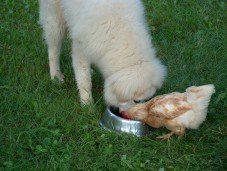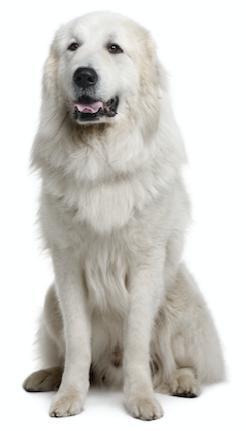The first image is the image on the left, the second image is the image on the right. Considering the images on both sides, is "An image shows more than one animal with its face in a round bowl, and at least one of the animals is a white dog." valid? Answer yes or no. Yes. The first image is the image on the left, the second image is the image on the right. Considering the images on both sides, is "The dog in the right image has food in its mouth." valid? Answer yes or no. No. 